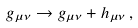<formula> <loc_0><loc_0><loc_500><loc_500>g _ { \mu \nu } \to g _ { \mu \nu } + h _ { \mu \nu } \, ,</formula> 